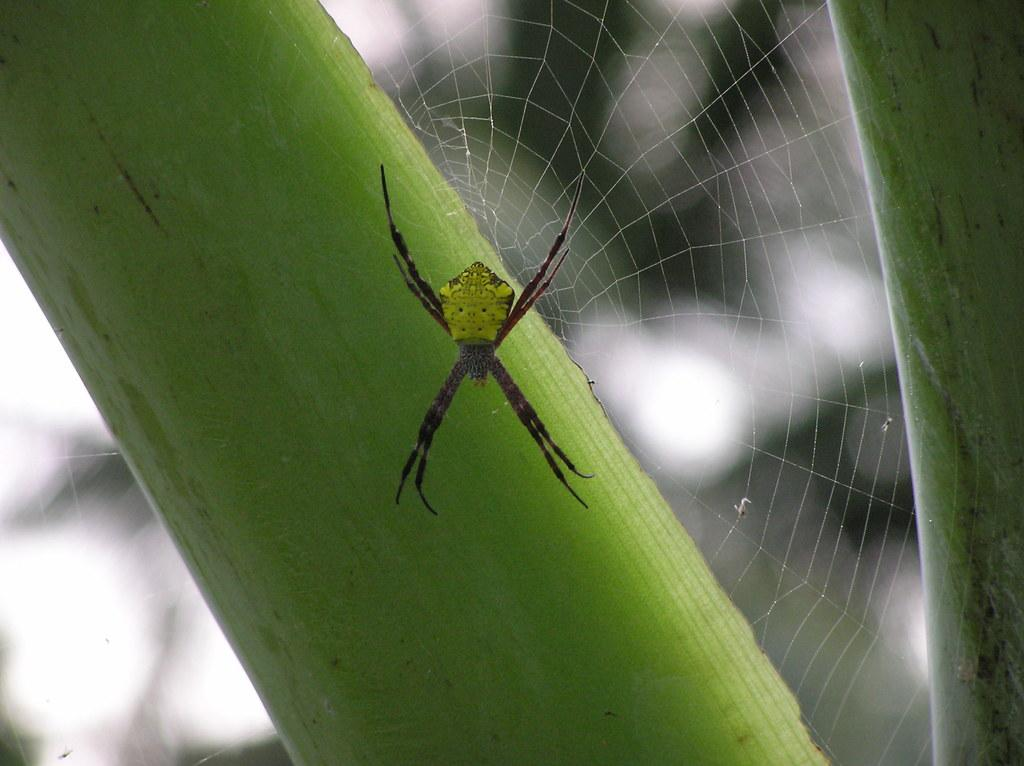What is the main subject of the image? There is a spider in the image. What is the spider associated with in the image? There is a spider web in the image, and the spider web is on a plant. How would you describe the overall appearance of the image? The background of the image is blurred. What type of iron can be seen hanging from the plant in the image? There is no iron present in the image; it features a spider and a spider web on a plant. How many icicles are visible on the plant in the image? There are no icicles present in the image; it features a spider and a spider web on a plant. 